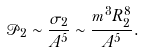Convert formula to latex. <formula><loc_0><loc_0><loc_500><loc_500>\mathcal { P } _ { 2 } \sim \frac { \sigma _ { 2 } } { A ^ { 5 } } \sim \frac { m ^ { 3 } R _ { 2 } ^ { 8 } } { A ^ { 5 } } .</formula> 